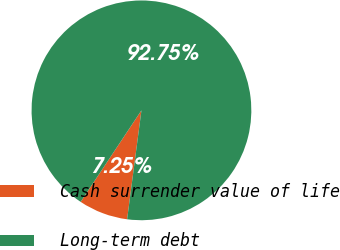Convert chart to OTSL. <chart><loc_0><loc_0><loc_500><loc_500><pie_chart><fcel>Cash surrender value of life<fcel>Long-term debt<nl><fcel>7.25%<fcel>92.75%<nl></chart> 